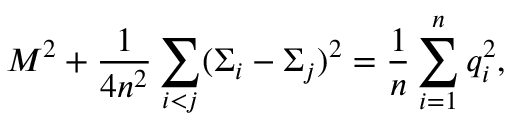<formula> <loc_0><loc_0><loc_500><loc_500>M ^ { 2 } + { \frac { 1 } { 4 n ^ { 2 } } } \sum _ { i < j } ( \Sigma _ { i } - \Sigma _ { j } ) ^ { 2 } = { \frac { 1 } { n } } \sum _ { i = 1 } ^ { n } q _ { i } ^ { 2 } ,</formula> 